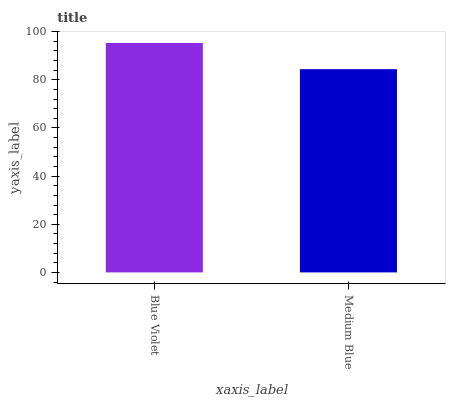Is Medium Blue the minimum?
Answer yes or no. Yes. Is Blue Violet the maximum?
Answer yes or no. Yes. Is Medium Blue the maximum?
Answer yes or no. No. Is Blue Violet greater than Medium Blue?
Answer yes or no. Yes. Is Medium Blue less than Blue Violet?
Answer yes or no. Yes. Is Medium Blue greater than Blue Violet?
Answer yes or no. No. Is Blue Violet less than Medium Blue?
Answer yes or no. No. Is Blue Violet the high median?
Answer yes or no. Yes. Is Medium Blue the low median?
Answer yes or no. Yes. Is Medium Blue the high median?
Answer yes or no. No. Is Blue Violet the low median?
Answer yes or no. No. 